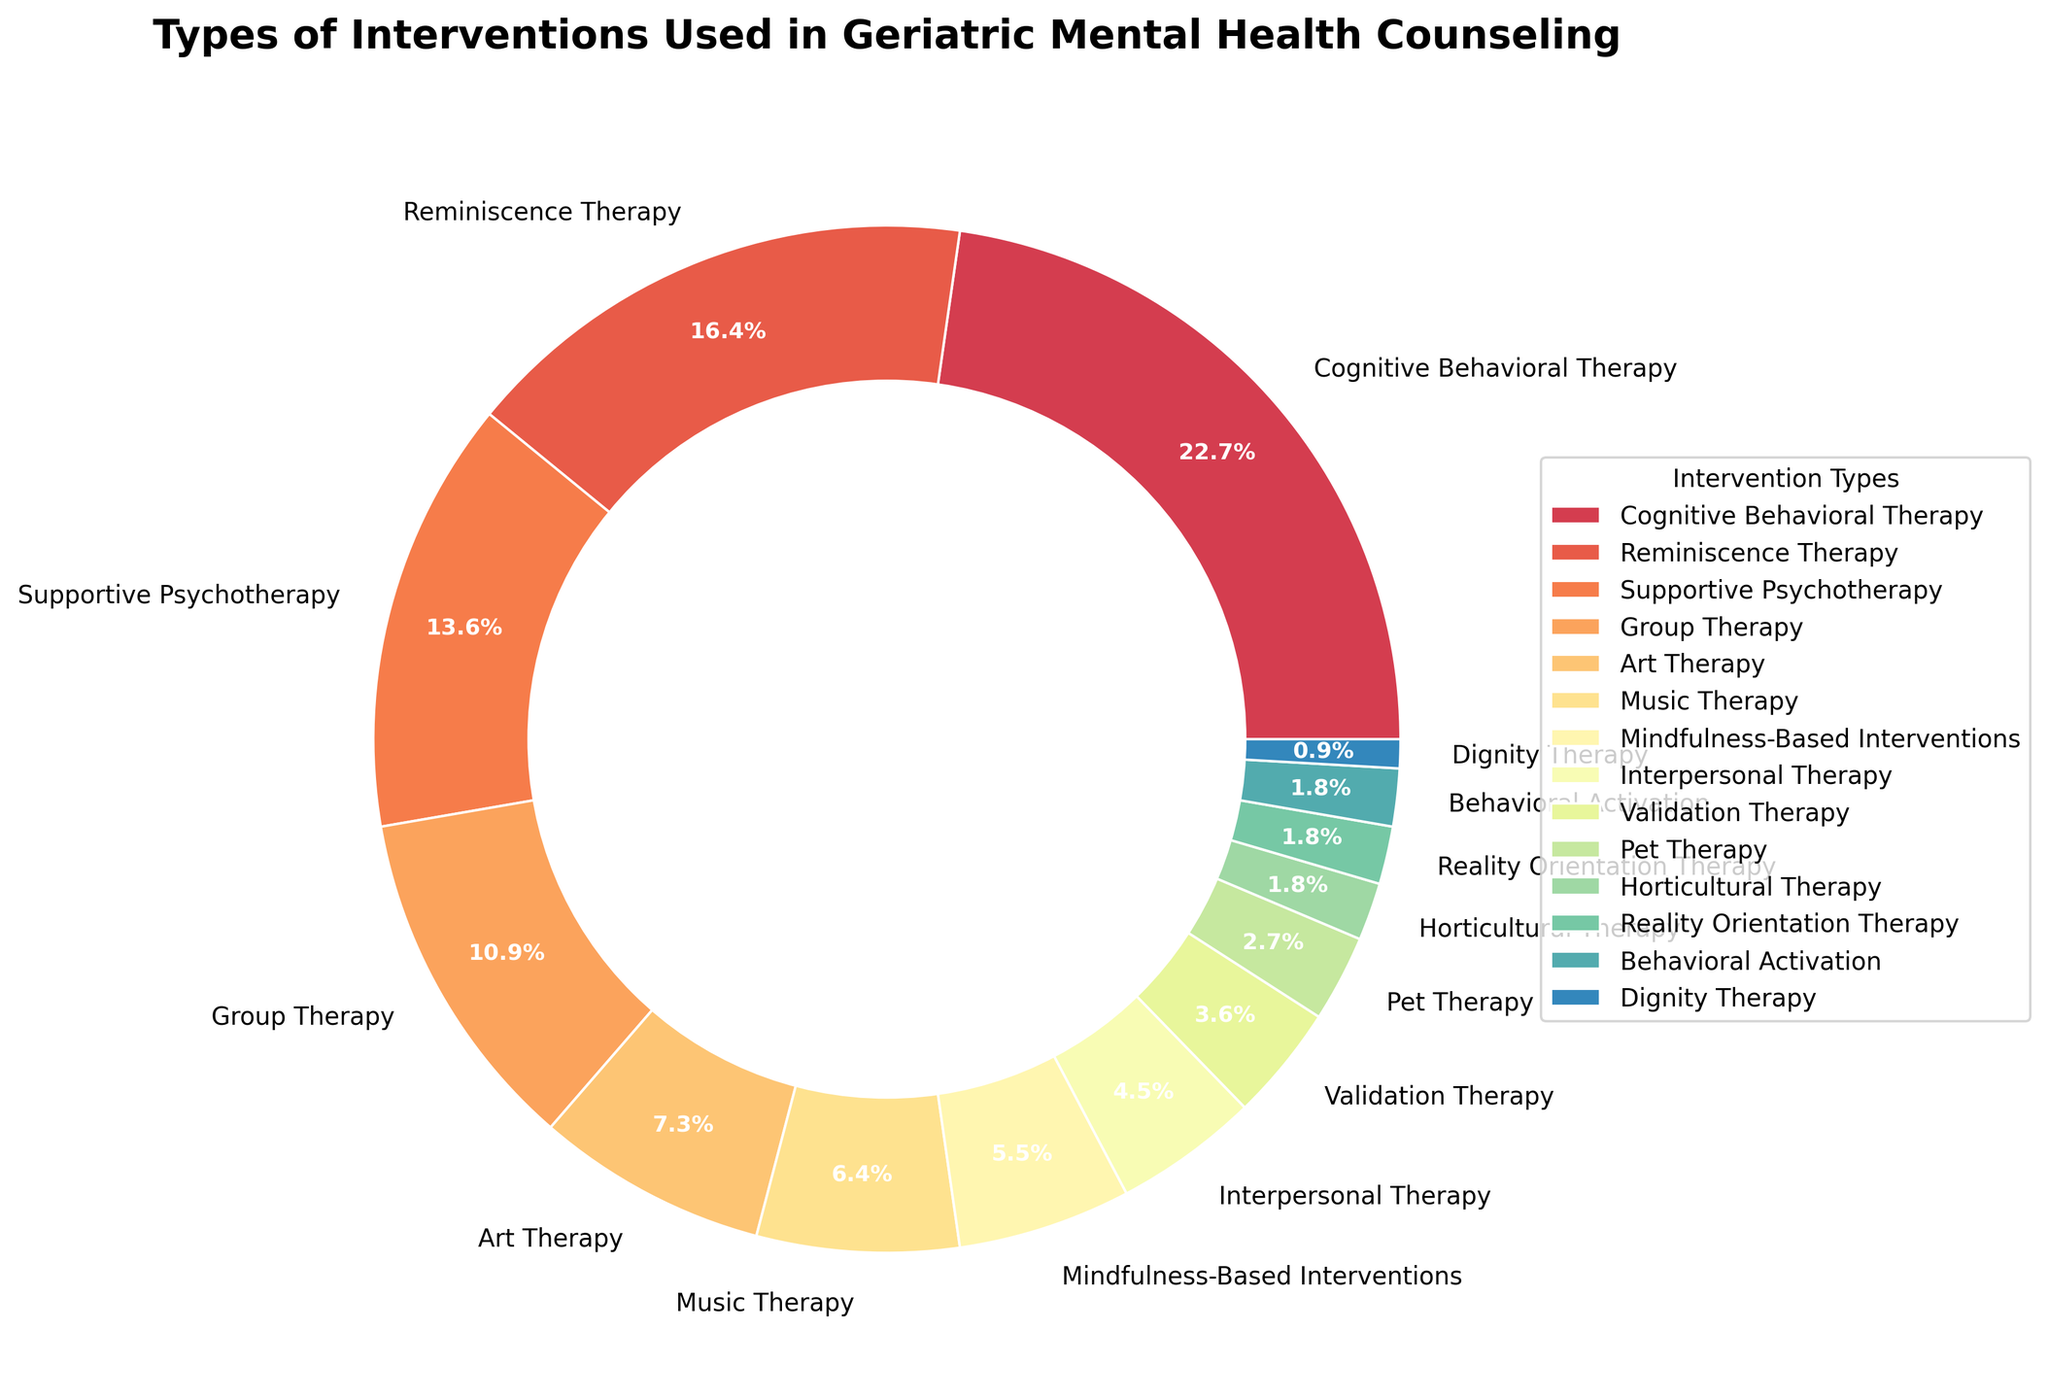Which intervention type has the largest percentage? By looking at the pie chart, find the largest wedge and read the label. The label indicates which intervention type has the largest percentage.
Answer: Cognitive Behavioral Therapy Which three intervention types make up the smallest percentages? Look at the pie chart and identify the three smallest wedges by size. Read their labels to identify the corresponding intervention types.
Answer: Dignity Therapy, Horticultural Therapy, Reality Orientation Therapy What is the combined percentage of Cognitive Behavioral Therapy and Supportive Psychotherapy? Find the percentages for Cognitive Behavioral Therapy (25%) and Supportive Psychotherapy (15%) in the chart, then add these two values together: 25 + 15 = 40
Answer: 40% Is Group Therapy more prevalent than Music Therapy? Locate the wedges for Group Therapy and Music Therapy and compare their sizes and percentages. Group Therapy is 12%, and Music Therapy is 7%, so Group Therapy is more prevalent.
Answer: Yes How many intervention types have a percentage less than 5%? Examine the chart to identify the wedges with labels specifying a percentage smaller than 5%. Count these wedges. There are 5 wedges: Interpersonal Therapy, Validation Therapy, Pet Therapy, Horticultural Therapy, and Dignity Therapy.
Answer: 5 What percentage of interventions fall under therapy types that involve the arts? Identify the interventions related to arts: Art Therapy (8%) and Music Therapy (7%). Add these percentages: 8 + 7 = 15
Answer: 15% Which therapies together make up more than half of the total percentage? Identify the largest wedges and sum their percentages until the total exceeds 50%. Cognitive Behavioral Therapy (25%), Reminiscence Therapy (18%), and Supportive Psychotherapy (15%) together make 25 + 18 + 15 = 58
Answer: Cognitive Behavioral Therapy, Reminiscence Therapy, Supportive Psychotherapy Is Pet Therapy less universally applied than Interpersonal Therapy? Compare the percentages of Pet Therapy (3%) and Interpersonal Therapy (5%) as shown in the chart. Pet Therapy's percentage is lower than Interpersonal Therapy's.
Answer: Yes What is the total percentage of therapies focused on past experiences and identity (Reminiscence Therapy and Dignity Therapy)? Find the percentages for Reminiscence Therapy (18%) and Dignity Therapy (1%), then sum these values: 18 + 1 = 19
Answer: 19% What is the difference in percentages between the most and least common intervention types? Find the percentage for the most common (Cognitive Behavioral Therapy, 25%) and the least common (Dignity Therapy, 1%) and subtract the smaller from the larger: 25 - 1 = 24
Answer: 24 